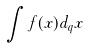<formula> <loc_0><loc_0><loc_500><loc_500>\int f ( x ) d _ { q } x</formula> 